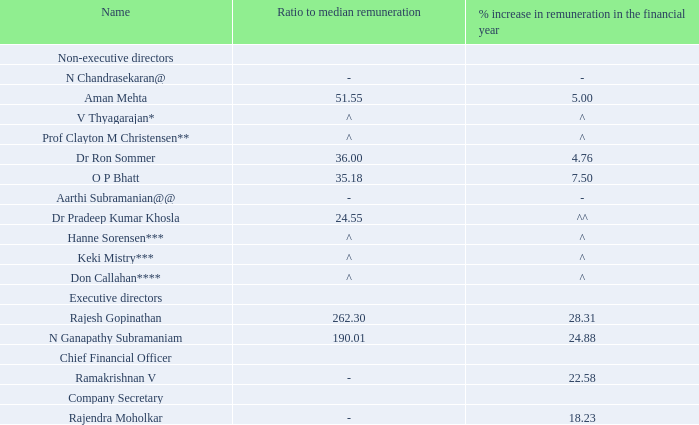@ As a policy, N Chandrasekaran, Chairman, has abstained from receiving commission from the Company and hence not stated.
@@ In line with the internal guidelines of the Company, no payment is made towards commission to the Non-Executive Directors of the Company, who are in full time employment with any other Tata company and hence not stated.
* Relinquished the position of Independent Director w.e.f. July 10, 2018.
** Relinquished the position of Independent Director w.e.f. September 28, 2018.
*** Appointed as an Additional and Independent Director w.e.f. December 18, 2018.
**** Appointed as an Additional and Independent Director w.e.f. January 10, 2019.
^ Since the remuneration is only for part of the year, the ratio of their remuneration to median remuneration and percentage increase in remuneration is not comparable and hence, not stated.
^^ Remuneration received in FY 2019 is not comparable with remuneration received in FY 2018 and hence, not stated.
Particulars of employees
The information required under Section 197 of the Act read with Rule 5 of the Companies (Appointment and
Remuneration of Managerial Personnel) Rules, 2014, are given below:
a. The ratio of the remuneration of each director to the median remuneration of the employees of the Company and percentage increase in remuneration of each Director, Chief Executive Officer, Chief Financial Officer and Company Secretary in the financial year:
b. The percentage increase in the median remuneration of employees in the financial year: 3.70 percent
c. The number of permanent employees on the rolls of Company: 424,285
d. Average percentile increase already made in the salaries of employees other than the managerial personnel in the last financial year and its comparison with the percentile increase in the managerial remuneration and justification thereof and point out if there are any exceptional circumstances for increase in the managerial remuneration:
The average annual increase was 6 percent in India. However, during the course of the year, the total increase is approximately 7.2 percent, after accounting for promotions and other event based compensation revisions. Employees outside India received a wage increase varying from 2 percent to 5 percent. The increase in remuneration is in line with the market trends in the respective countries.
Increase in the managerial remuneration for the year was 14.66 percent.
e. Affirmation that the remuneration is as per the remuneration policy of the Company:
The Company affirms that the remuneration is as per the remuneration policy of the Company.
f. The statement containing names of top ten employees in terms of remuneration drawn and the particulars of employees as required under Section 197(12) of the Act read with Rule 5(2) and 5(3) of the Companies (Appointment and Remuneration of Managerial Personnel) Rules, 2014, is provided in a separate annexure forming part of this report. Further, the report and the accounts are being sent to the Members excluding the aforesaid annexure. In terms of Section 136 of the Act, the said annexure is open for inspection at the Registered Office of the Company. Any Member interested in obtaining a copy of the same may write to the Company Secretary.
Which Director had the highest % increase in remuneration in the financial year? Rajesh gopinathan. Why was the remuneration for N Chandrasekaran not stated? As a policy, n chandrasekaran, chairman, has abstained from receiving commission from the company and hence not stated. What is the difference between the percentage increase in the median remuneration of employees and managerial remuneration for the financial year?
Answer scale should be: percent. 14.66 - 3.70 
Answer: 10.96. What is the average % increase in remuneration in the financial year for the Director, Chief Executive Officer, Chief Financial Officer and Company Secretary?
Answer scale should be: percent. (5.00 + 4.76 + 7.50 + 28.31 + 24.88 + 22.58 + 18.23)/7 
Answer: 15.89. What is the difference in ratio to median remuneration between the two Executive Directors? 262.30 - 190.01 
Answer: 72.29. What information does the second table column provide? The ratio of the remuneration of each director to the median remuneration of the employees of the company. 